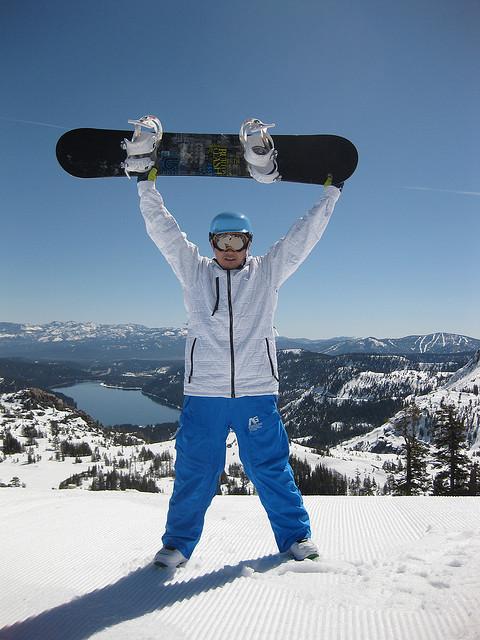Can you see any unfrozen water?
Be succinct. Yes. What is the terrain?
Give a very brief answer. Snow. Why is the person raising his arms?
Keep it brief. Holding snowboard. 